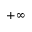<formula> <loc_0><loc_0><loc_500><loc_500>+ \infty</formula> 